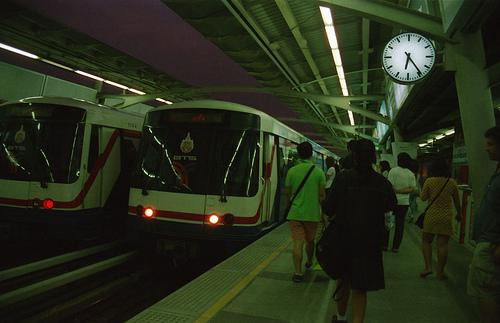Question: why was the picture taken?
Choices:
A. To show the person.
B. To show the house.
C. To show the subway.
D. To show the mountains.
Answer with the letter. Answer: C Question: who is in the picture?
Choices:
A. Drivers.
B. Children.
C. Transit riders.
D. Animals.
Answer with the letter. Answer: C Question: what color is the caution line?
Choices:
A. Red.
B. Orange.
C. Yellow.
D. Blue.
Answer with the letter. Answer: C Question: how many trains are there?
Choices:
A. 4.
B. 2.
C. 8.
D. 6.
Answer with the letter. Answer: B 